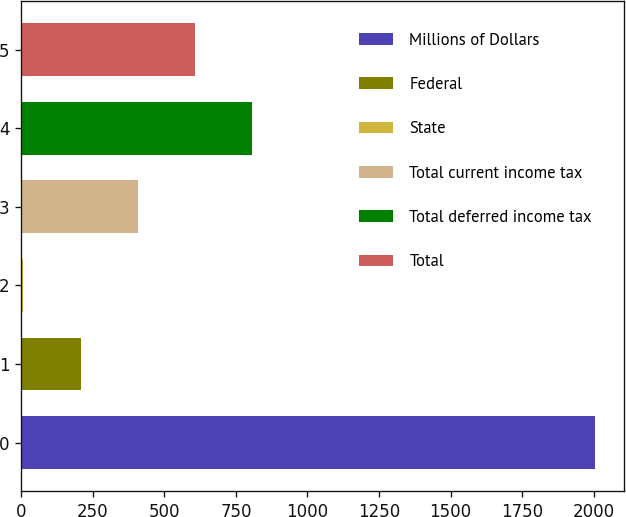Convert chart to OTSL. <chart><loc_0><loc_0><loc_500><loc_500><bar_chart><fcel>Millions of Dollars<fcel>Federal<fcel>State<fcel>Total current income tax<fcel>Total deferred income tax<fcel>Total<nl><fcel>2004<fcel>207.6<fcel>8<fcel>407.2<fcel>806.4<fcel>606.8<nl></chart> 